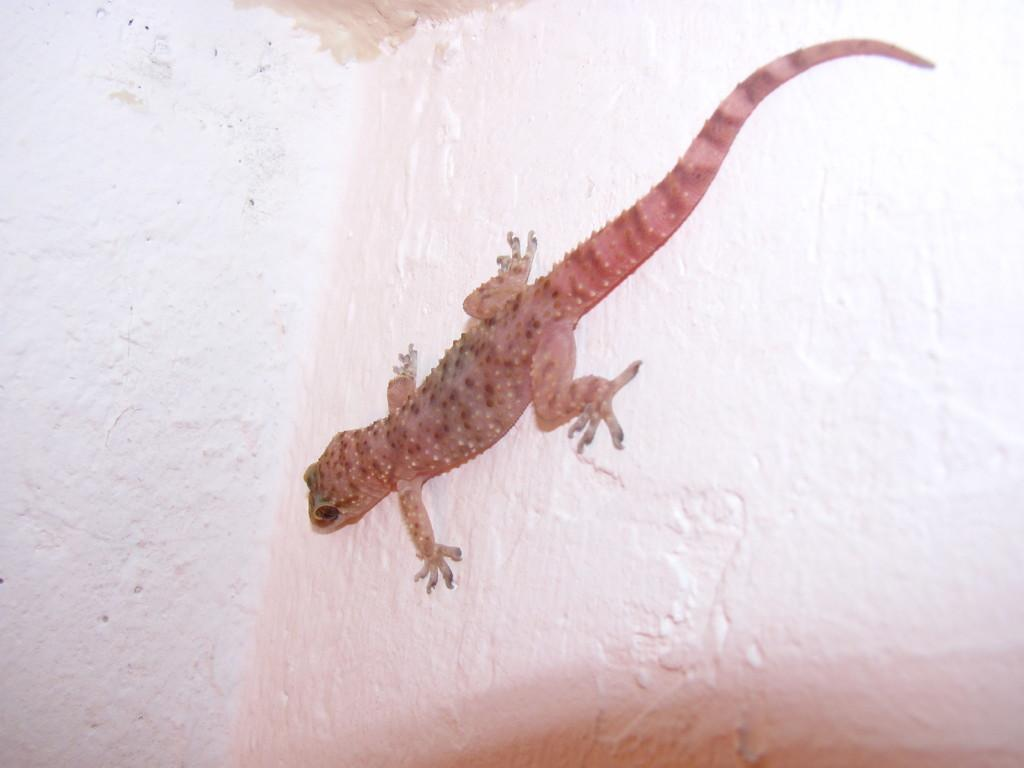What type of animal is in the image? There is a lizard in the image. Where is the lizard located? The lizard is on the wall. What type of sky is visible in the image? There is no sky visible in the image, as the focus is on the lizard on the wall. Can you see a kitten playing with the lizard in the image? There is no kitten present in the image; it only features a lizard on the wall. 